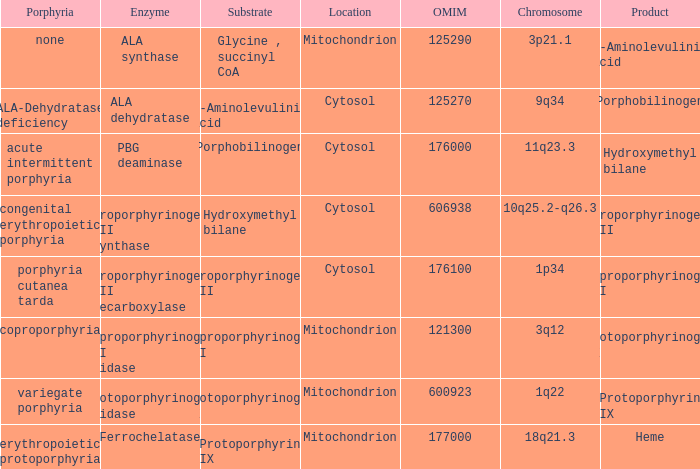Which substrate has an OMIM of 176000? Porphobilinogen. 